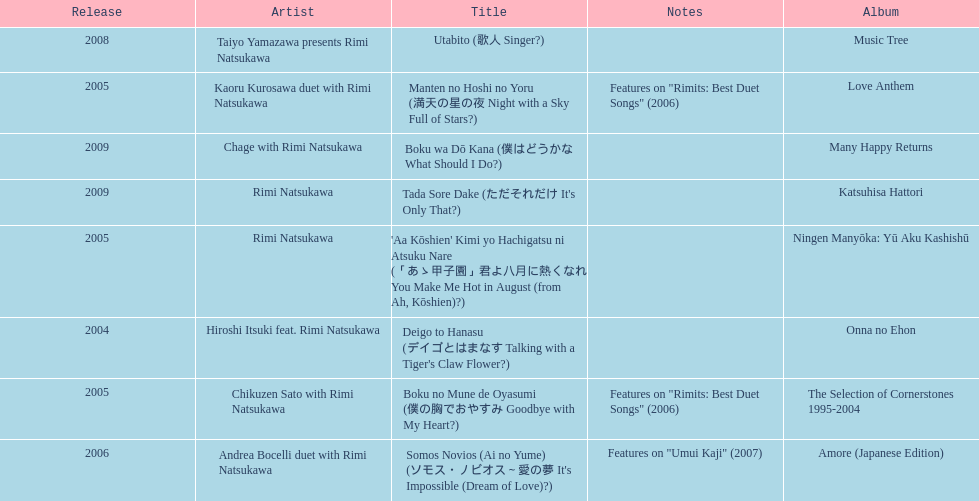What has been the last song this artist has made an other appearance on? Tada Sore Dake. 